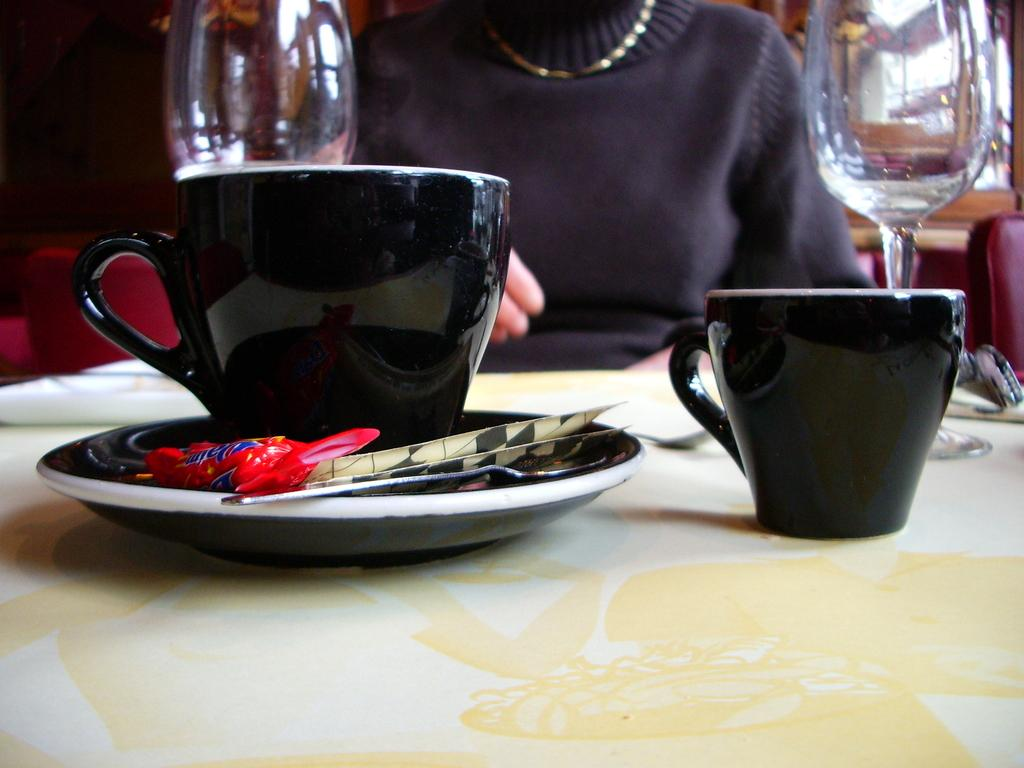What type of containers are visible in the image? There is a cup and a glass in the image. Where are the cup and glass located? Both the cup and glass are on a table. Is there anyone else present in the image besides the containers? Yes, there is a person sitting in front of the table. What type of invention is the person wearing in the image? There is no mention of an invention or any clothing in the image. 